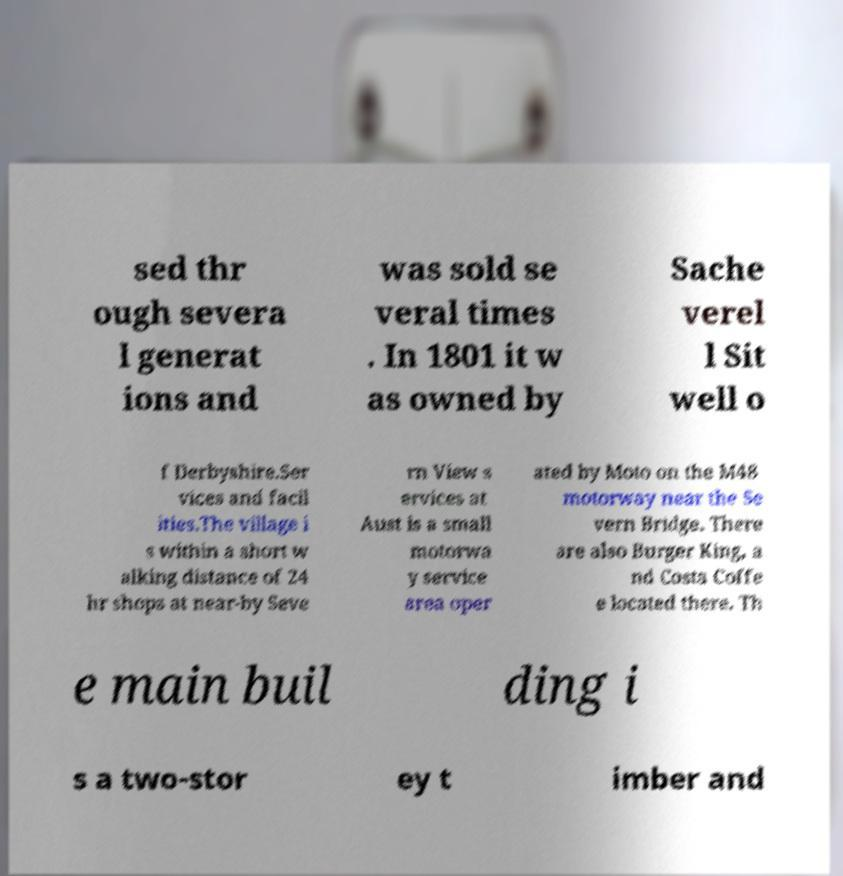For documentation purposes, I need the text within this image transcribed. Could you provide that? sed thr ough severa l generat ions and was sold se veral times . In 1801 it w as owned by Sache verel l Sit well o f Derbyshire.Ser vices and facil ities.The village i s within a short w alking distance of 24 hr shops at near-by Seve rn View s ervices at Aust is a small motorwa y service area oper ated by Moto on the M48 motorway near the Se vern Bridge. There are also Burger King, a nd Costa Coffe e located there. Th e main buil ding i s a two-stor ey t imber and 